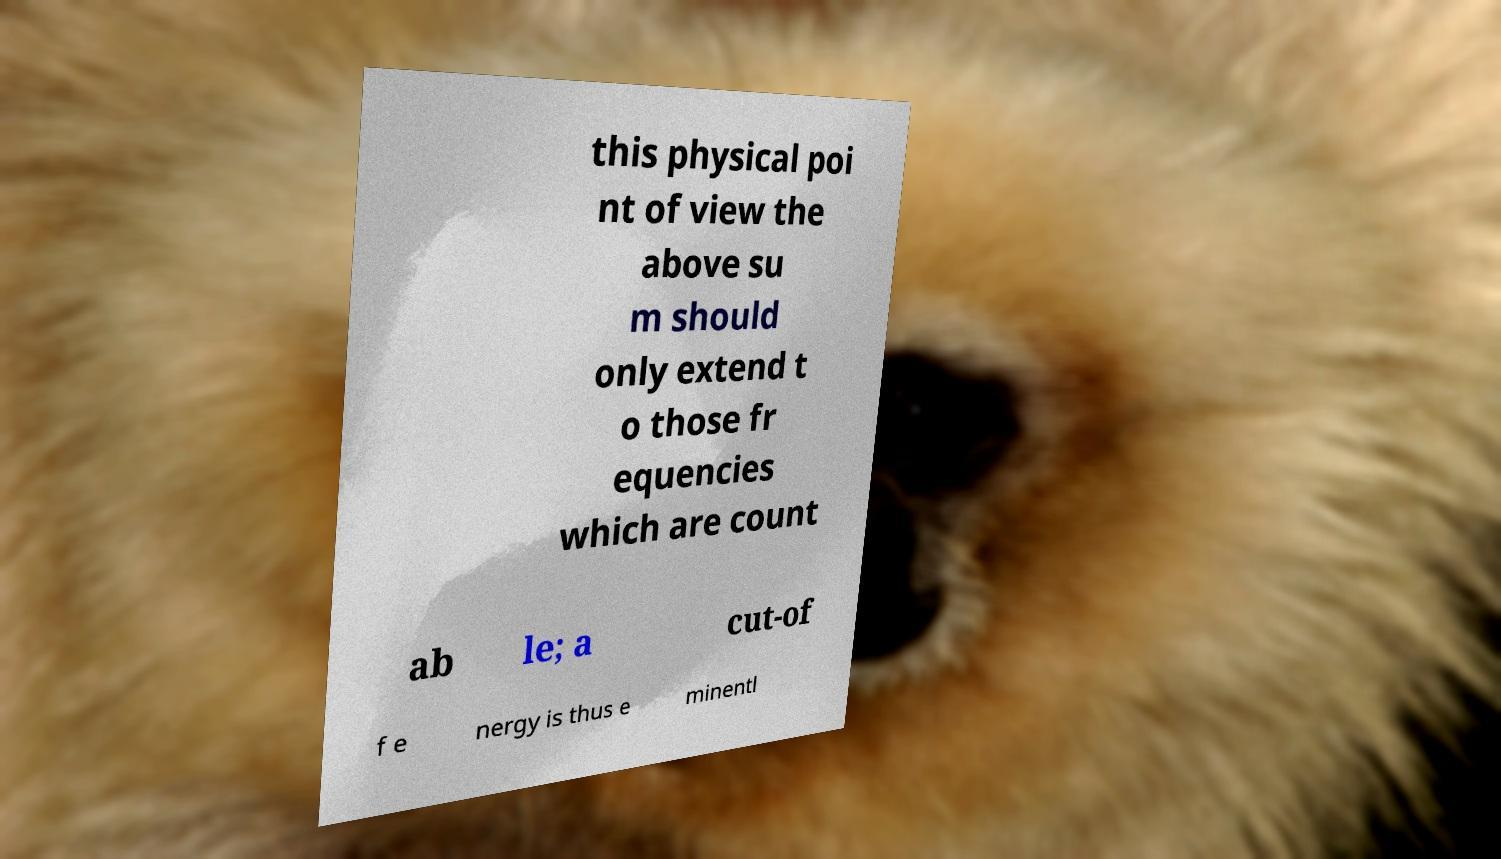Please identify and transcribe the text found in this image. this physical poi nt of view the above su m should only extend t o those fr equencies which are count ab le; a cut-of f e nergy is thus e minentl 